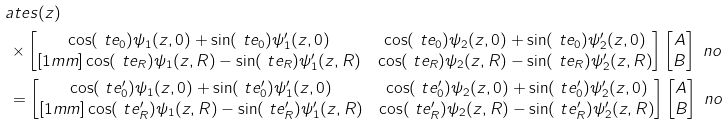<formula> <loc_0><loc_0><loc_500><loc_500>& \L a t e s ( z ) \\ & \, \times \begin{bmatrix} \cos ( \ t e _ { 0 } ) \psi _ { 1 } ( z , 0 ) + \sin ( \ t e _ { 0 } ) \psi _ { 1 } ^ { \prime } ( z , 0 ) & \cos ( \ t e _ { 0 } ) \psi _ { 2 } ( z , 0 ) + \sin ( \ t e _ { 0 } ) \psi _ { 2 } ^ { \prime } ( z , 0 ) \\ [ 1 m m ] \cos ( \ t e _ { R } ) \psi _ { 1 } ( z , R ) - \sin ( \ t e _ { R } ) \psi _ { 1 } ^ { \prime } ( z , R ) & \cos ( \ t e _ { R } ) \psi _ { 2 } ( z , R ) - \sin ( \ t e _ { R } ) \psi _ { 2 } ^ { \prime } ( z , R ) \end{bmatrix} \begin{bmatrix} A \\ B \end{bmatrix} \ n o \\ & \, = \begin{bmatrix} \cos ( \ t e _ { 0 } ^ { \prime } ) \psi _ { 1 } ( z , 0 ) + \sin ( \ t e _ { 0 } ^ { \prime } ) \psi _ { 1 } ^ { \prime } ( z , 0 ) & \cos ( \ t e _ { 0 } ^ { \prime } ) \psi _ { 2 } ( z , 0 ) + \sin ( \ t e _ { 0 } ^ { \prime } ) \psi _ { 2 } ^ { \prime } ( z , 0 ) \\ [ 1 m m ] \cos ( \ t e _ { R } ^ { \prime } ) \psi _ { 1 } ( z , R ) - \sin ( \ t e _ { R } ^ { \prime } ) \psi _ { 1 } ^ { \prime } ( z , R ) & \cos ( \ t e _ { R } ^ { \prime } ) \psi _ { 2 } ( z , R ) - \sin ( \ t e _ { R } ^ { \prime } ) \psi _ { 2 } ^ { \prime } ( z , R ) \end{bmatrix} \begin{bmatrix} A \\ B \end{bmatrix} \ n o</formula> 